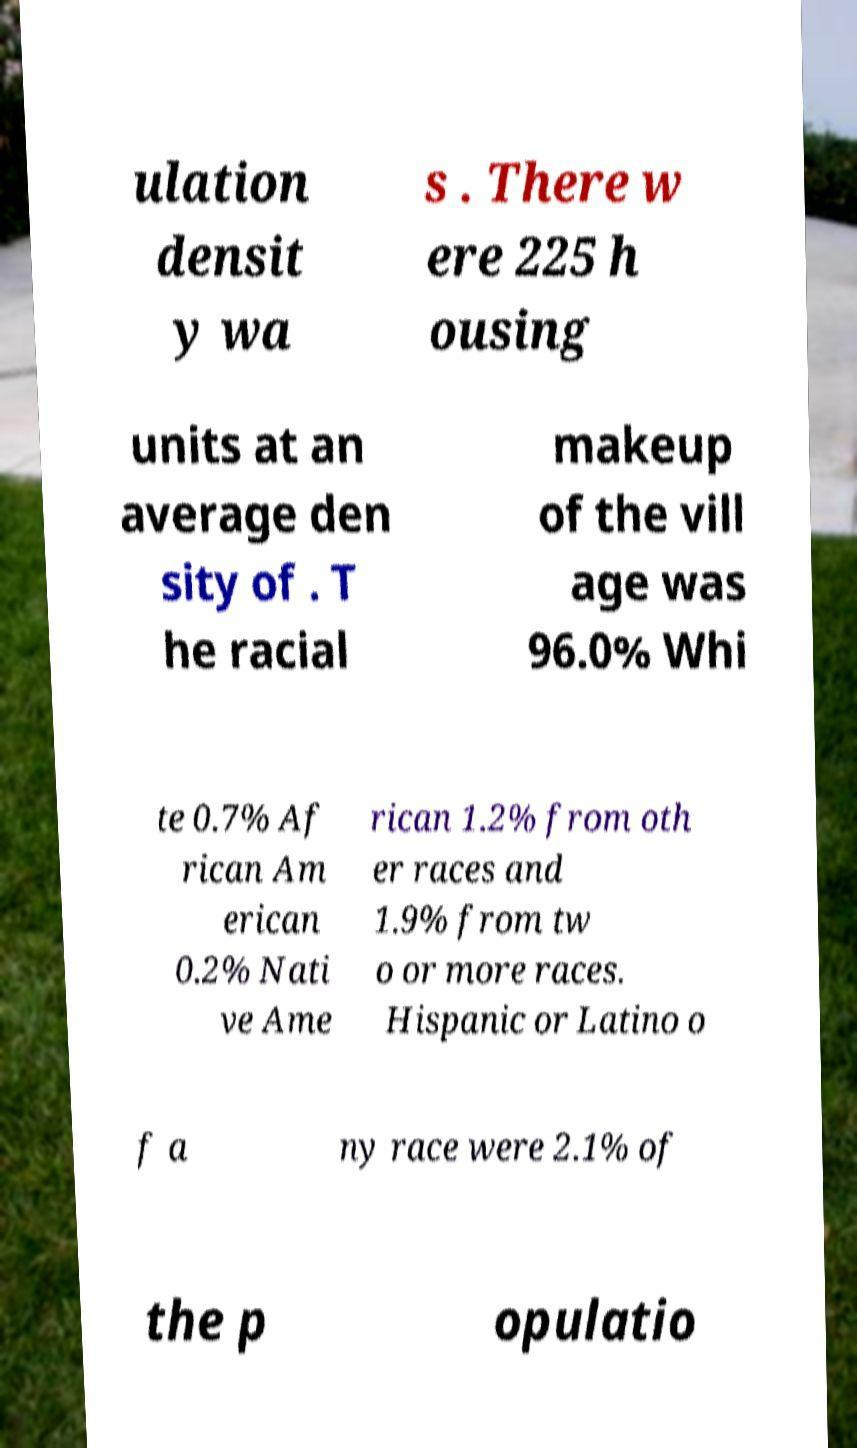For documentation purposes, I need the text within this image transcribed. Could you provide that? ulation densit y wa s . There w ere 225 h ousing units at an average den sity of . T he racial makeup of the vill age was 96.0% Whi te 0.7% Af rican Am erican 0.2% Nati ve Ame rican 1.2% from oth er races and 1.9% from tw o or more races. Hispanic or Latino o f a ny race were 2.1% of the p opulatio 